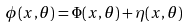<formula> <loc_0><loc_0><loc_500><loc_500>\phi ( x , \theta ) = \Phi ( x , \theta ) + \eta ( x , \theta )</formula> 